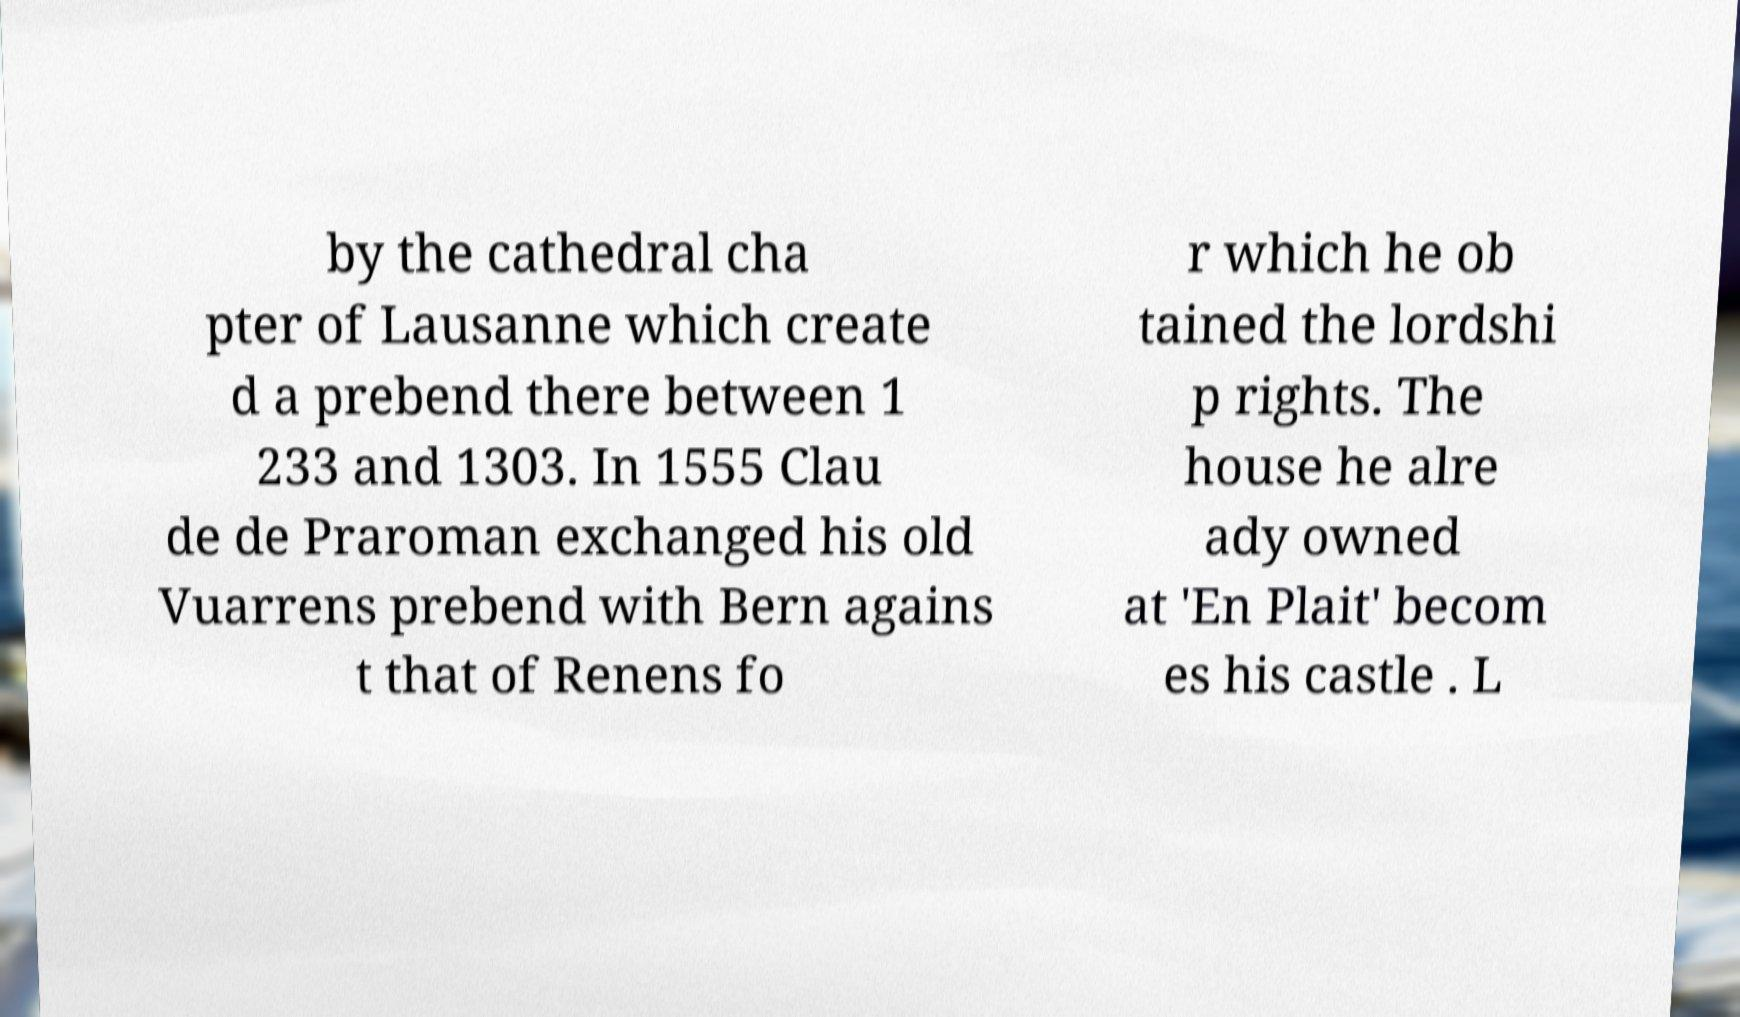Can you read and provide the text displayed in the image?This photo seems to have some interesting text. Can you extract and type it out for me? by the cathedral cha pter of Lausanne which create d a prebend there between 1 233 and 1303. In 1555 Clau de de Praroman exchanged his old Vuarrens prebend with Bern agains t that of Renens fo r which he ob tained the lordshi p rights. The house he alre ady owned at 'En Plait' becom es his castle . L 